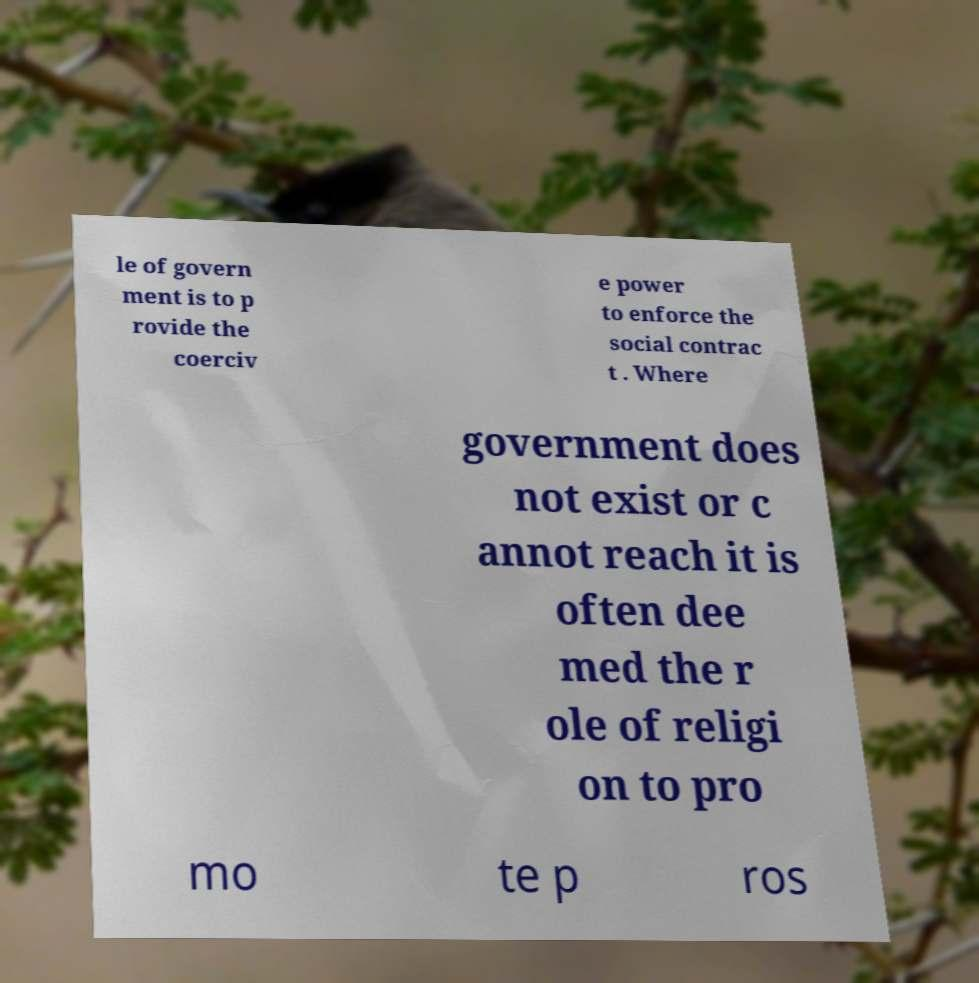I need the written content from this picture converted into text. Can you do that? le of govern ment is to p rovide the coerciv e power to enforce the social contrac t . Where government does not exist or c annot reach it is often dee med the r ole of religi on to pro mo te p ros 